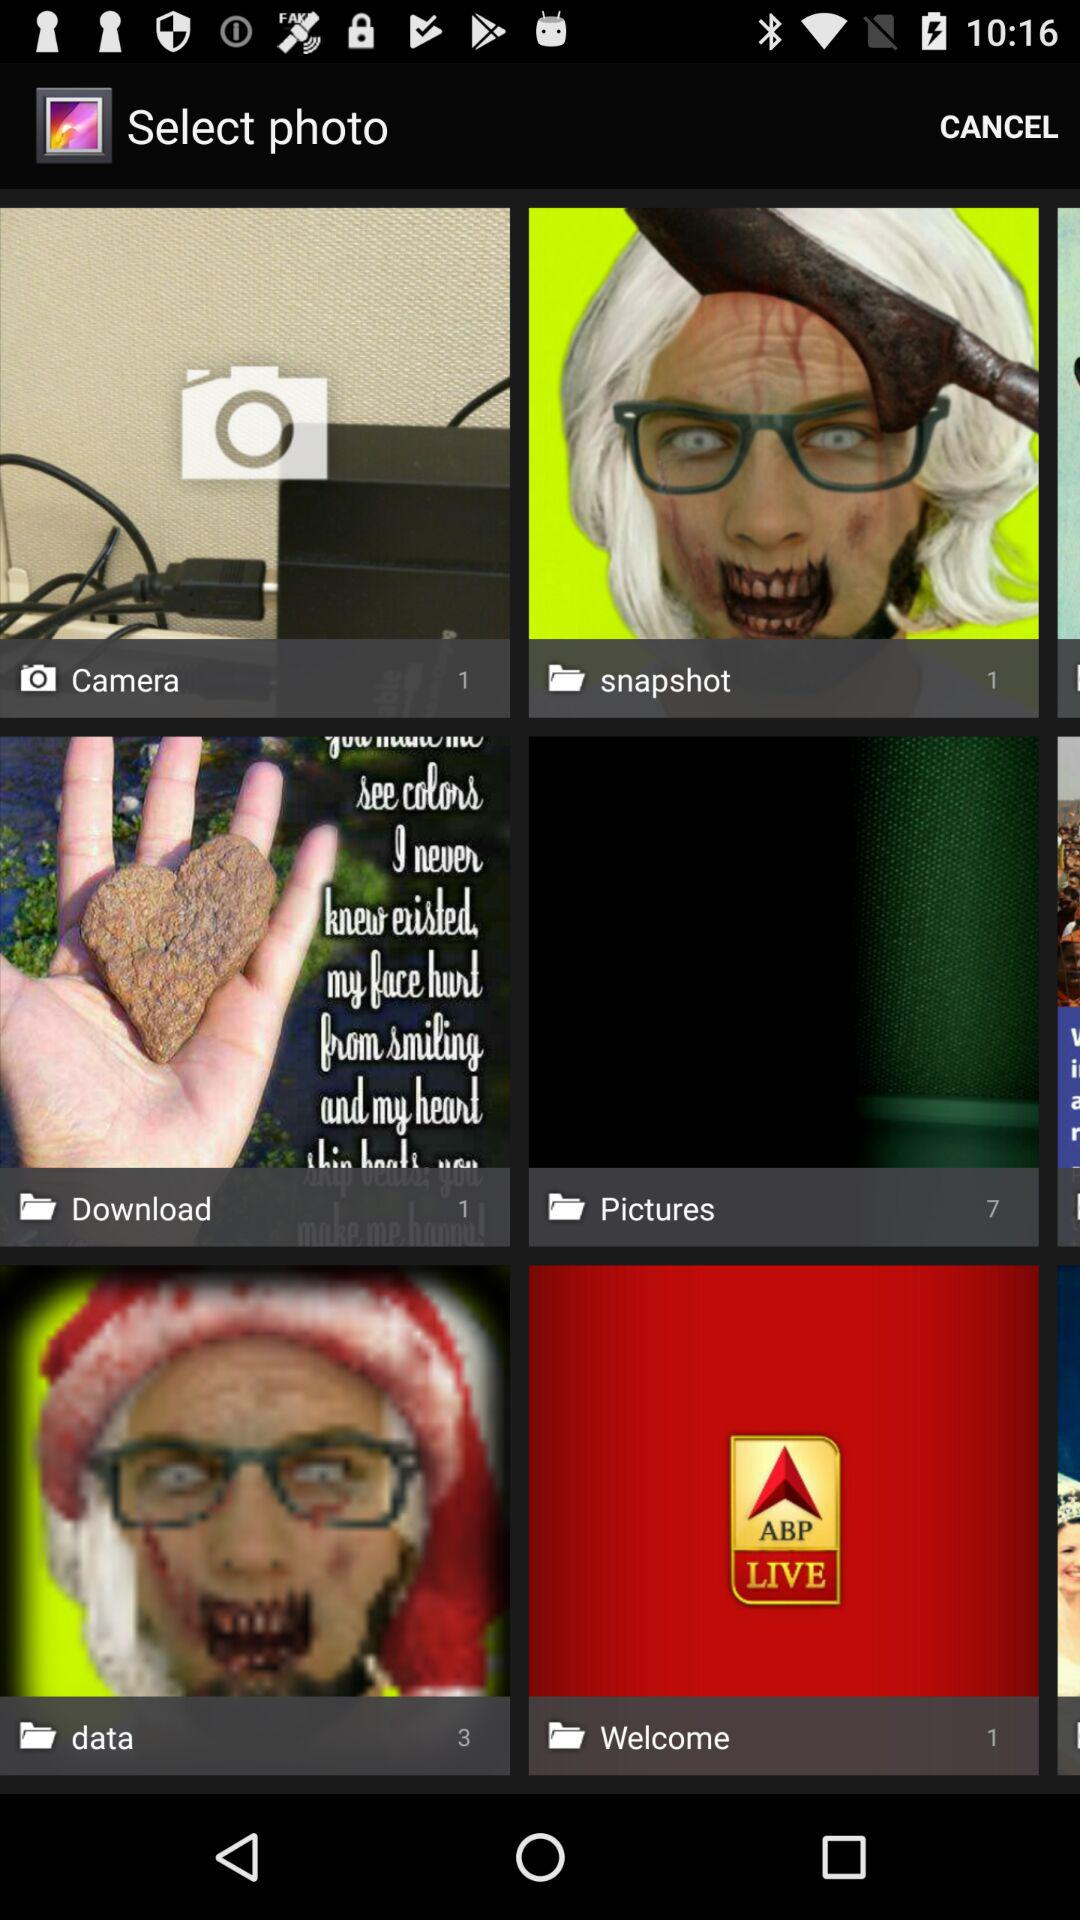How many pictures are in the Download folder? There is 1 picture. 